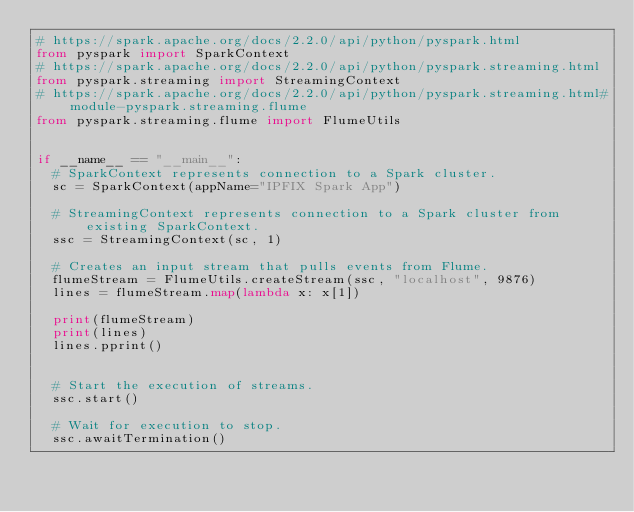Convert code to text. <code><loc_0><loc_0><loc_500><loc_500><_Python_># https://spark.apache.org/docs/2.2.0/api/python/pyspark.html
from pyspark import SparkContext
# https://spark.apache.org/docs/2.2.0/api/python/pyspark.streaming.html
from pyspark.streaming import StreamingContext
# https://spark.apache.org/docs/2.2.0/api/python/pyspark.streaming.html#module-pyspark.streaming.flume
from pyspark.streaming.flume import FlumeUtils


if __name__ == "__main__":
	# SparkContext represents connection to a Spark cluster.
	sc = SparkContext(appName="IPFIX Spark App")
	
	# StreamingContext represents connection to a Spark cluster from existing SparkContext.
	ssc = StreamingContext(sc, 1)
	
	# Creates an input stream that pulls events from Flume.
	flumeStream = FlumeUtils.createStream(ssc, "localhost", 9876)
	lines = flumeStream.map(lambda x: x[1])
	
	print(flumeStream)
	print(lines)
	lines.pprint()
	
	
	# Start the execution of streams.
	ssc.start()
	
	# Wait for execution to stop.
	ssc.awaitTermination()
</code> 